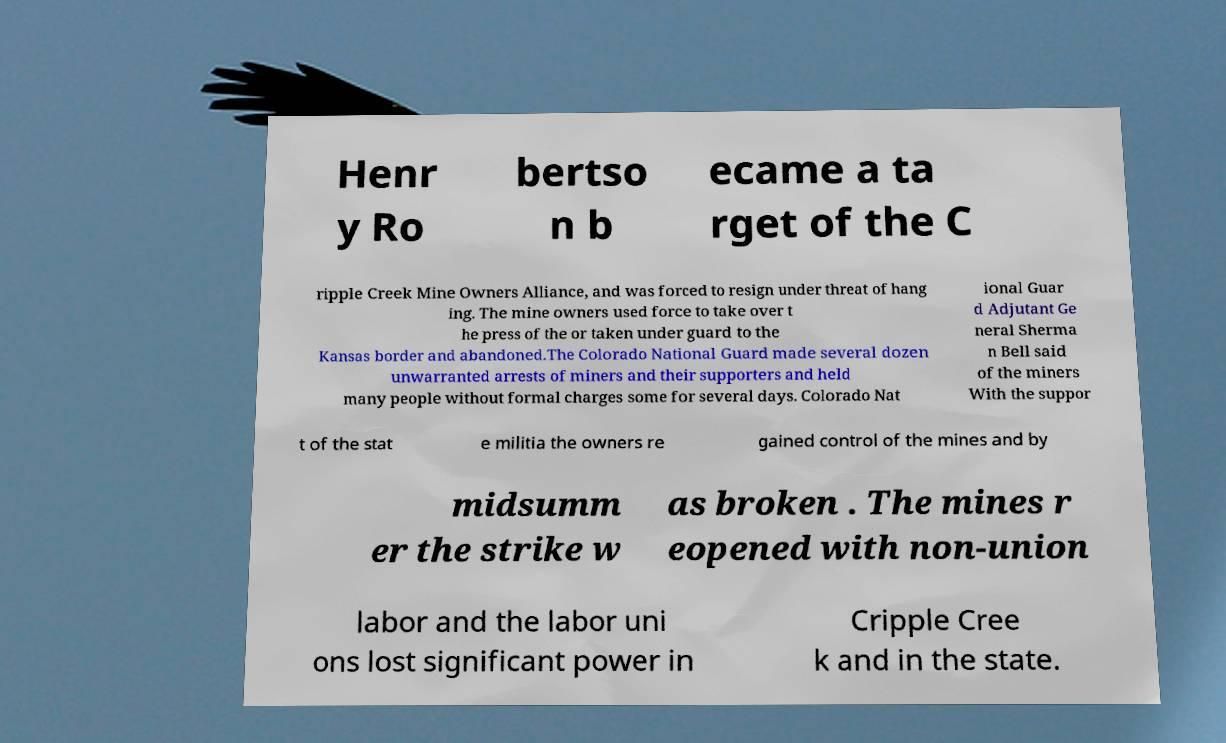Can you accurately transcribe the text from the provided image for me? Henr y Ro bertso n b ecame a ta rget of the C ripple Creek Mine Owners Alliance, and was forced to resign under threat of hang ing. The mine owners used force to take over t he press of the or taken under guard to the Kansas border and abandoned.The Colorado National Guard made several dozen unwarranted arrests of miners and their supporters and held many people without formal charges some for several days. Colorado Nat ional Guar d Adjutant Ge neral Sherma n Bell said of the miners With the suppor t of the stat e militia the owners re gained control of the mines and by midsumm er the strike w as broken . The mines r eopened with non-union labor and the labor uni ons lost significant power in Cripple Cree k and in the state. 